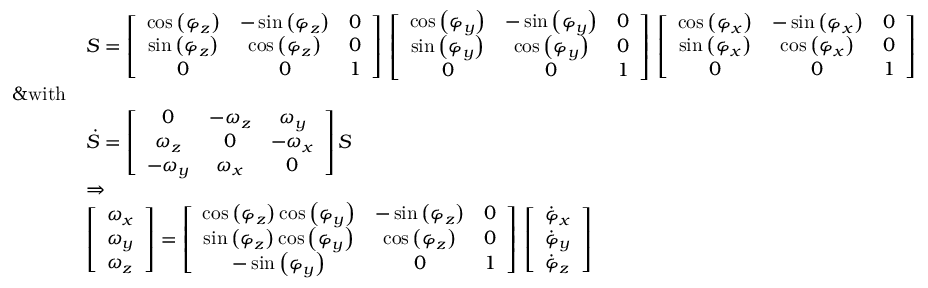<formula> <loc_0><loc_0><loc_500><loc_500>\begin{array} { r l } & { \boldsymbol S = \left [ \begin{array} { c c c } { \cos \left ( \varphi _ { z } \right ) } & { - \sin \left ( \varphi _ { z } \right ) } & { 0 } \\ { \sin \left ( \varphi _ { z } \right ) } & { \cos \left ( \varphi _ { z } \right ) } & { 0 } \\ { 0 } & { 0 } & { 1 } \end{array} \right ] \, \left [ \begin{array} { c c c } { \cos \left ( \varphi _ { y } \right ) } & { - \sin \left ( \varphi _ { y } \right ) } & { 0 } \\ { \sin \left ( \varphi _ { y } \right ) } & { \cos \left ( \varphi _ { y } \right ) } & { 0 } \\ { 0 } & { 0 } & { 1 } \end{array} \right ] \, \left [ \begin{array} { c c c } { \cos \left ( \varphi _ { x } \right ) } & { - \sin \left ( \varphi _ { x } \right ) } & { 0 } \\ { \sin \left ( \varphi _ { x } \right ) } & { \cos \left ( \varphi _ { x } \right ) } & { 0 } \\ { 0 } & { 0 } & { 1 } \end{array} \right ] } \\ { \& w i t h } \\ & { \dot { S } = \left [ \begin{array} { c c c } { 0 } & { - \omega _ { z } } & { \omega _ { y } } \\ { \omega _ { z } } & { 0 } & { - \omega _ { x } } \\ { - \omega _ { y } } & { \omega _ { x } } & { 0 } \end{array} \right ] \boldsymbol S \, } \\ & { \Rightarrow } \\ & { \left [ \begin{array} { l } { \omega _ { x } } \\ { \omega _ { y } } \\ { \omega _ { z } } \end{array} \right ] = \left [ \begin{array} { c c c } { \cos \left ( \varphi _ { z } \right ) \cos \left ( \varphi _ { y } \right ) } & { - \sin \left ( \varphi _ { z } \right ) } & { 0 } \\ { \sin \left ( \varphi _ { z } \right ) \cos \left ( \varphi _ { y } \right ) } & { \cos \left ( \varphi _ { z } \right ) } & { 0 } \\ { - \sin \left ( \varphi _ { y } \right ) } & { 0 } & { 1 } \end{array} \right ] \, \left [ \begin{array} { l } { \dot { \varphi } _ { x } } \\ { \dot { \varphi } _ { y } } \\ { \dot { \varphi } _ { z } } \end{array} \right ] } \end{array}</formula> 